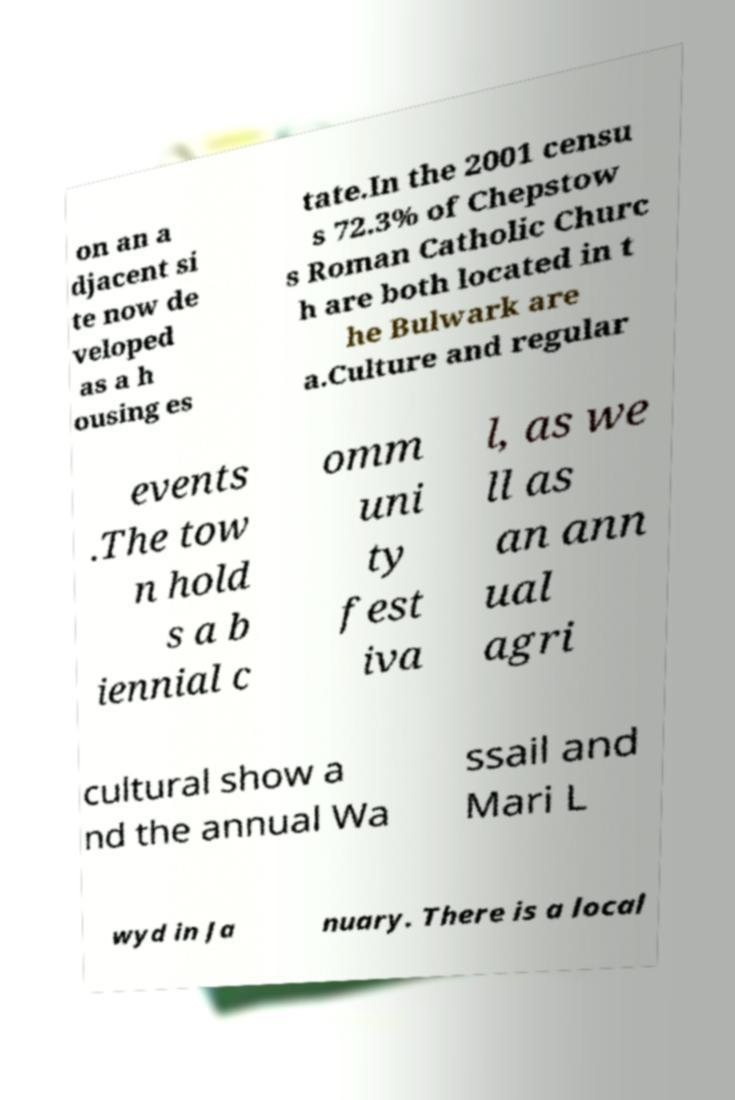Please identify and transcribe the text found in this image. on an a djacent si te now de veloped as a h ousing es tate.In the 2001 censu s 72.3% of Chepstow s Roman Catholic Churc h are both located in t he Bulwark are a.Culture and regular events .The tow n hold s a b iennial c omm uni ty fest iva l, as we ll as an ann ual agri cultural show a nd the annual Wa ssail and Mari L wyd in Ja nuary. There is a local 